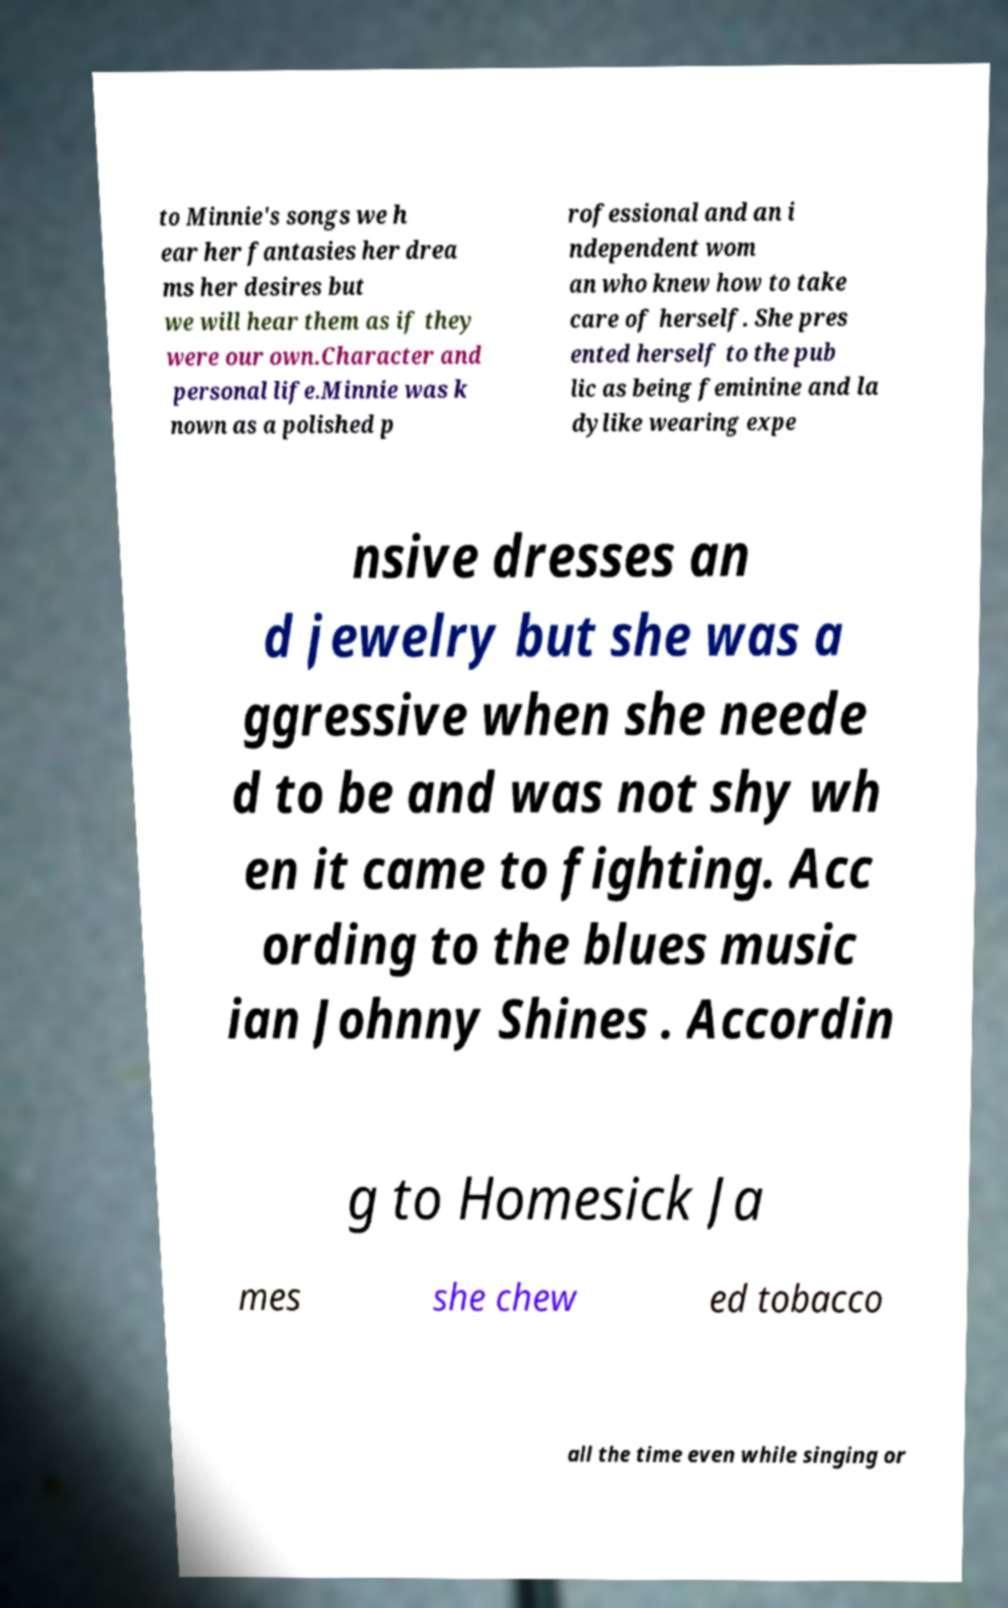There's text embedded in this image that I need extracted. Can you transcribe it verbatim? to Minnie's songs we h ear her fantasies her drea ms her desires but we will hear them as if they were our own.Character and personal life.Minnie was k nown as a polished p rofessional and an i ndependent wom an who knew how to take care of herself. She pres ented herself to the pub lic as being feminine and la dylike wearing expe nsive dresses an d jewelry but she was a ggressive when she neede d to be and was not shy wh en it came to fighting. Acc ording to the blues music ian Johnny Shines . Accordin g to Homesick Ja mes she chew ed tobacco all the time even while singing or 